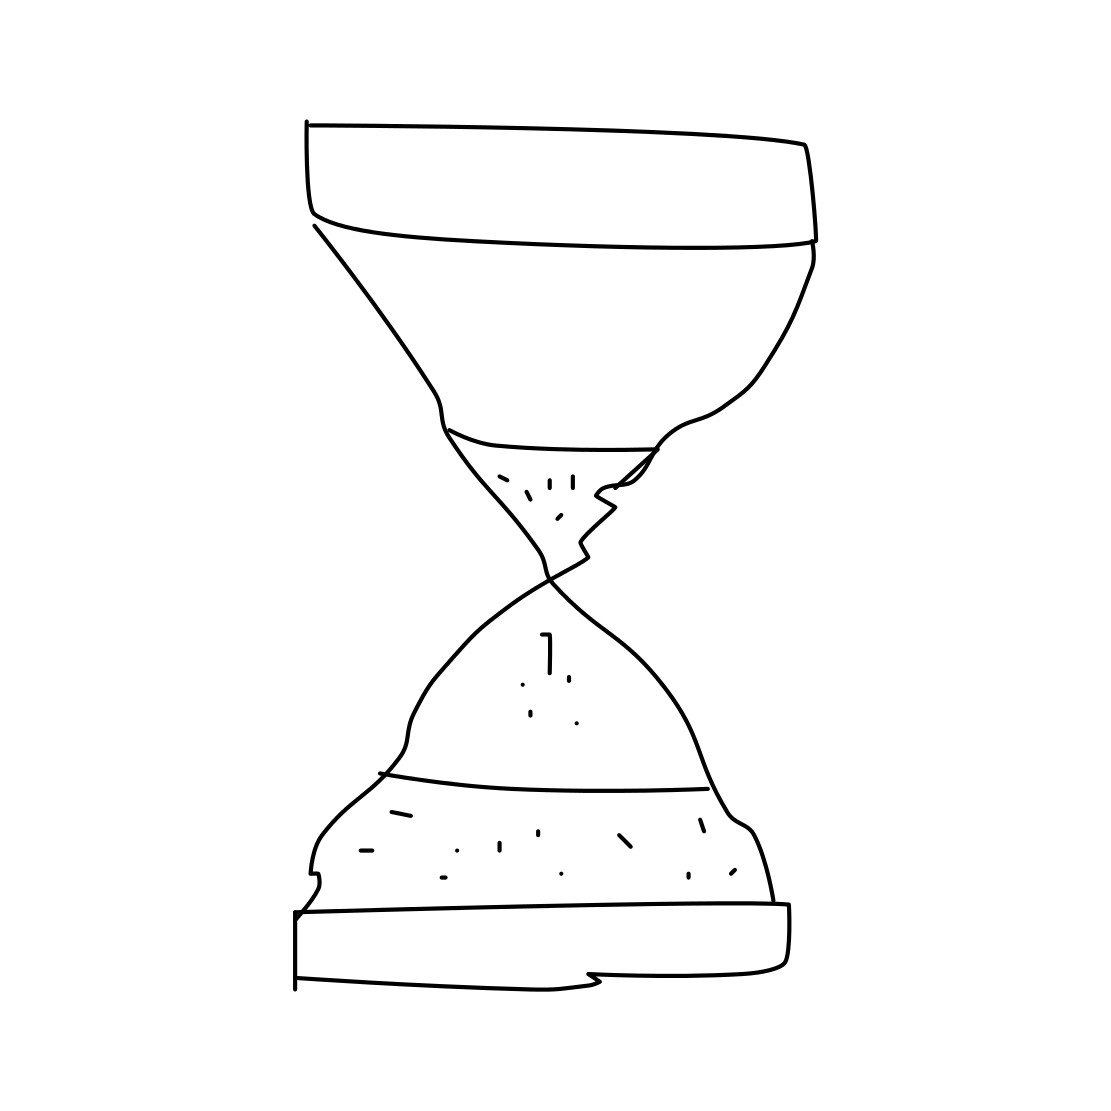Do hourglasses serve any practical purposes today? Today, hourglasses are largely decorative or are used ceremonially because digital timekeeping methods are more accurate and convenient for most practical purposes. However, hourglasses are still used in some traditional settings, like during board games to limit the time of a player's turn, or in cooking to time certain recipes. They can also serve as visual reminders of passing time during activities such as meditation or as teaching tools to demonstrate the concept of time to children. 